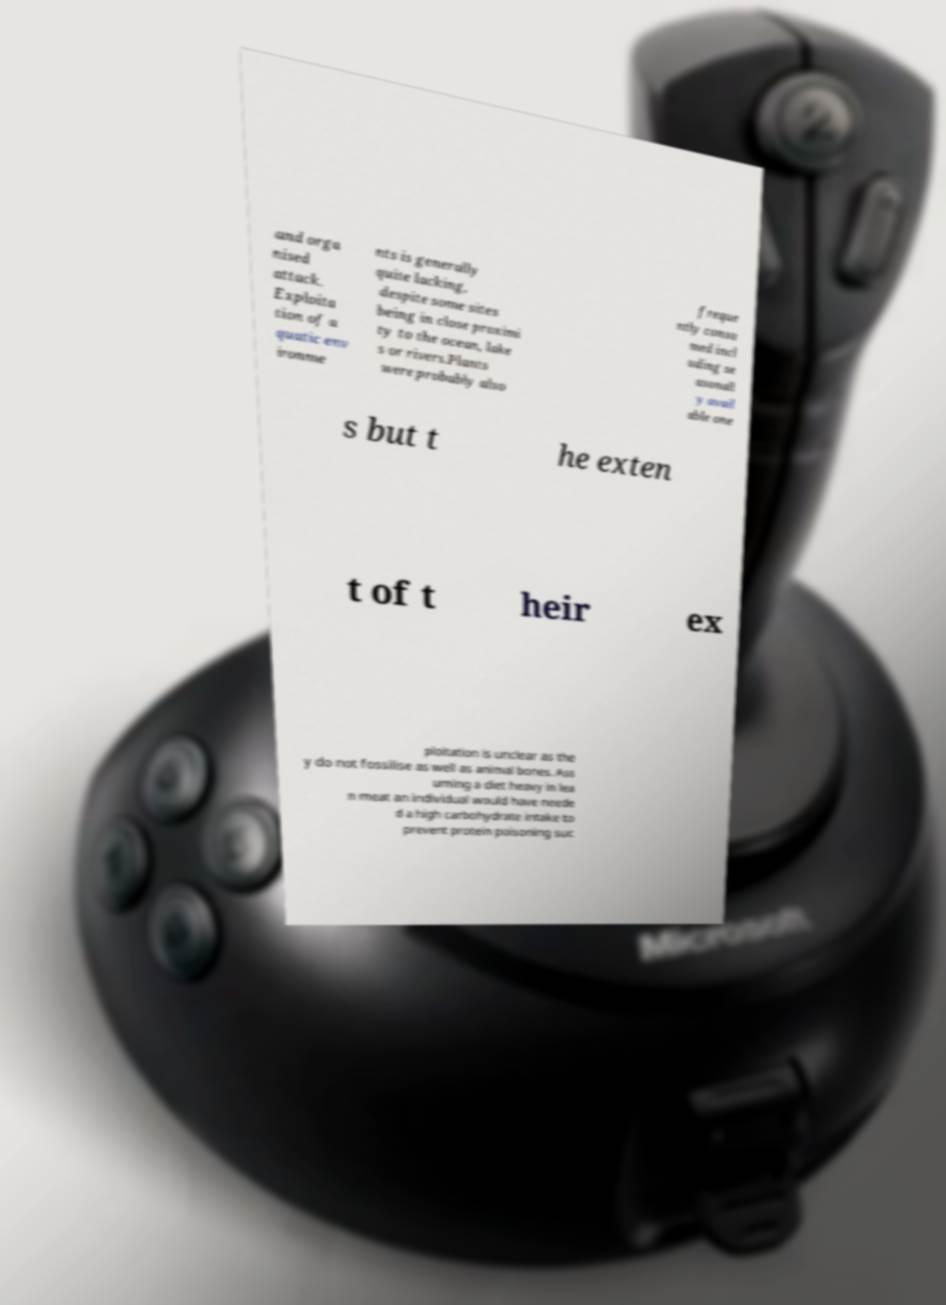Could you assist in decoding the text presented in this image and type it out clearly? and orga nised attack. Exploita tion of a quatic env ironme nts is generally quite lacking, despite some sites being in close proximi ty to the ocean, lake s or rivers.Plants were probably also freque ntly consu med incl uding se asonall y avail able one s but t he exten t of t heir ex ploitation is unclear as the y do not fossilise as well as animal bones. Ass uming a diet heavy in lea n meat an individual would have neede d a high carbohydrate intake to prevent protein poisoning suc 